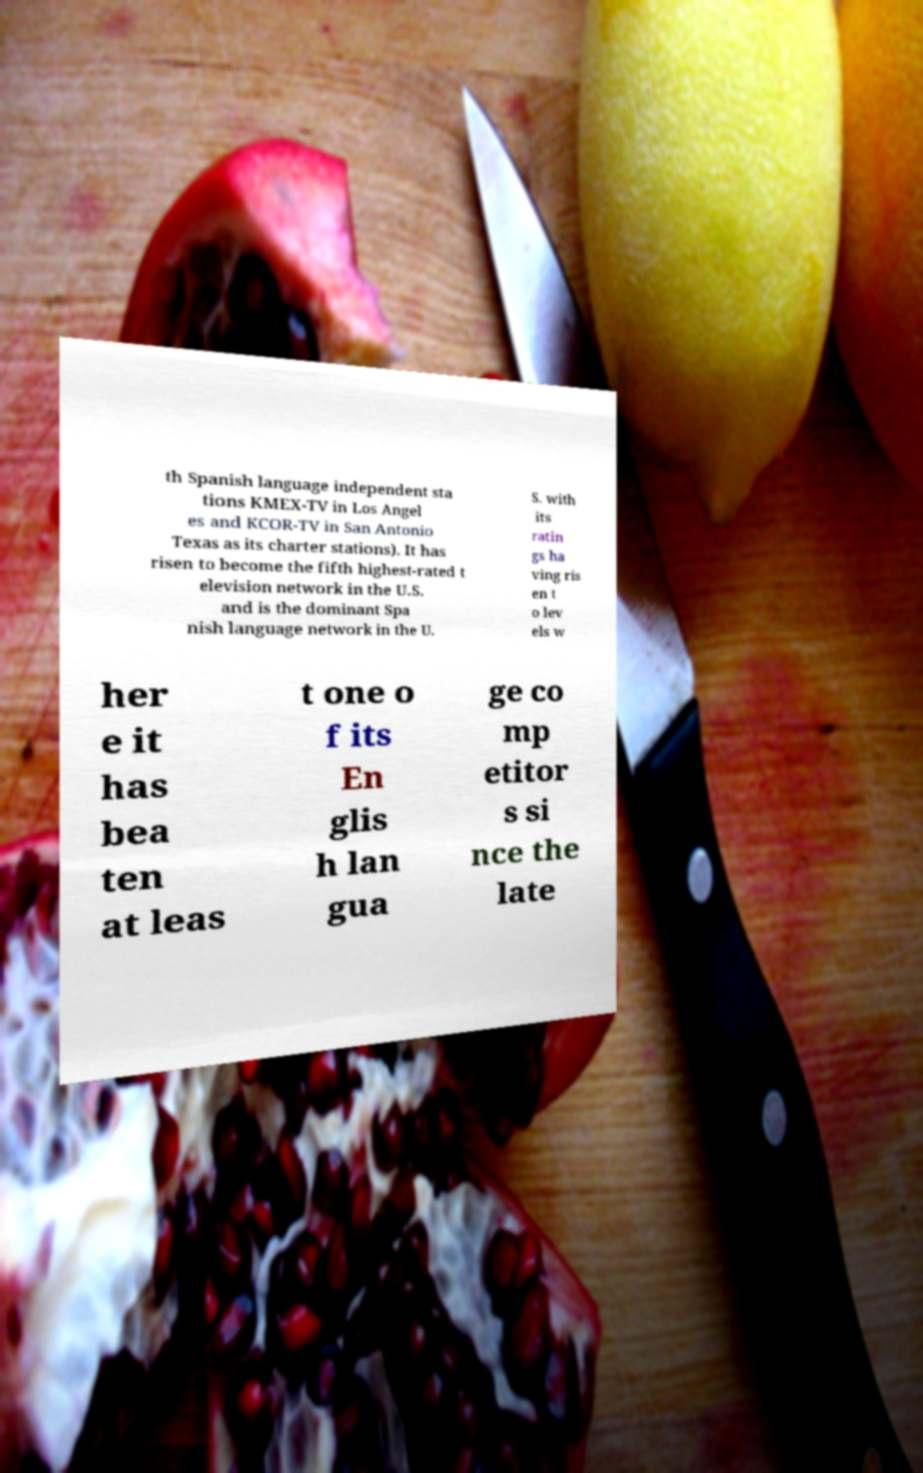I need the written content from this picture converted into text. Can you do that? th Spanish language independent sta tions KMEX-TV in Los Angel es and KCOR-TV in San Antonio Texas as its charter stations). It has risen to become the fifth highest-rated t elevision network in the U.S. and is the dominant Spa nish language network in the U. S. with its ratin gs ha ving ris en t o lev els w her e it has bea ten at leas t one o f its En glis h lan gua ge co mp etitor s si nce the late 